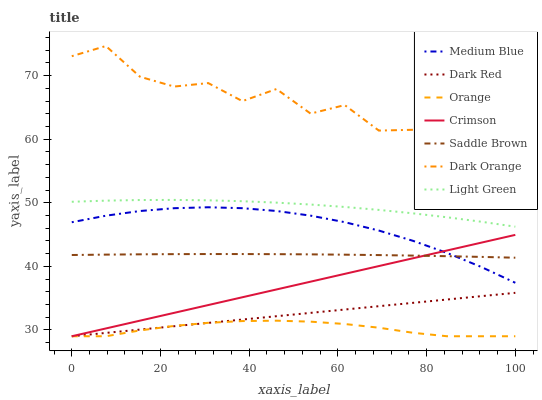Does Orange have the minimum area under the curve?
Answer yes or no. Yes. Does Dark Orange have the maximum area under the curve?
Answer yes or no. Yes. Does Dark Red have the minimum area under the curve?
Answer yes or no. No. Does Dark Red have the maximum area under the curve?
Answer yes or no. No. Is Dark Red the smoothest?
Answer yes or no. Yes. Is Dark Orange the roughest?
Answer yes or no. Yes. Is Medium Blue the smoothest?
Answer yes or no. No. Is Medium Blue the roughest?
Answer yes or no. No. Does Medium Blue have the lowest value?
Answer yes or no. No. Does Dark Orange have the highest value?
Answer yes or no. Yes. Does Dark Red have the highest value?
Answer yes or no. No. Is Orange less than Dark Orange?
Answer yes or no. Yes. Is Dark Orange greater than Medium Blue?
Answer yes or no. Yes. Does Orange intersect Dark Orange?
Answer yes or no. No. 